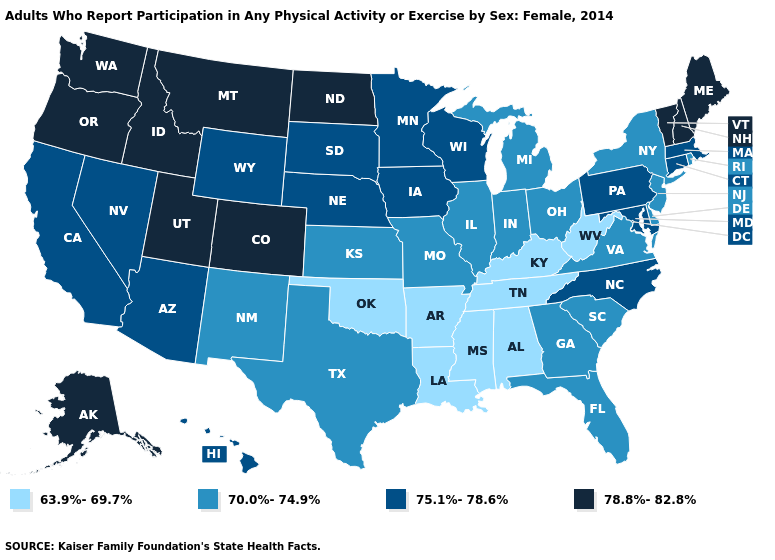Which states have the lowest value in the MidWest?
Quick response, please. Illinois, Indiana, Kansas, Michigan, Missouri, Ohio. What is the lowest value in the USA?
Quick response, please. 63.9%-69.7%. What is the lowest value in states that border Ohio?
Be succinct. 63.9%-69.7%. What is the value of New Hampshire?
Short answer required. 78.8%-82.8%. What is the value of Nevada?
Keep it brief. 75.1%-78.6%. Does Texas have a lower value than Tennessee?
Keep it brief. No. Does Michigan have the same value as Missouri?
Quick response, please. Yes. Is the legend a continuous bar?
Concise answer only. No. Which states have the highest value in the USA?
Give a very brief answer. Alaska, Colorado, Idaho, Maine, Montana, New Hampshire, North Dakota, Oregon, Utah, Vermont, Washington. What is the highest value in states that border New Hampshire?
Short answer required. 78.8%-82.8%. How many symbols are there in the legend?
Give a very brief answer. 4. Which states have the lowest value in the West?
Short answer required. New Mexico. Among the states that border Texas , does Oklahoma have the lowest value?
Give a very brief answer. Yes. Which states have the highest value in the USA?
Be succinct. Alaska, Colorado, Idaho, Maine, Montana, New Hampshire, North Dakota, Oregon, Utah, Vermont, Washington. Is the legend a continuous bar?
Be succinct. No. 